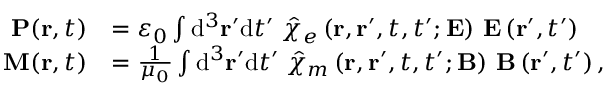<formula> <loc_0><loc_0><loc_500><loc_500>{ \begin{array} { r l } { P ( r , t ) } & { = \varepsilon _ { 0 } \int { d } ^ { 3 } r ^ { \prime } { d } t ^ { \prime } \, { \hat { \chi } } _ { e } \left ( r , r ^ { \prime } , t , t ^ { \prime } ; E \right ) \, E \left ( r ^ { \prime } , t ^ { \prime } \right ) } \\ { M ( r , t ) } & { = { \frac { 1 } { \mu _ { 0 } } } \int { d } ^ { 3 } r ^ { \prime } { d } t ^ { \prime } \, { \hat { \chi } } _ { m } \left ( r , r ^ { \prime } , t , t ^ { \prime } ; B \right ) \, B \left ( r ^ { \prime } , t ^ { \prime } \right ) , } \end{array} }</formula> 